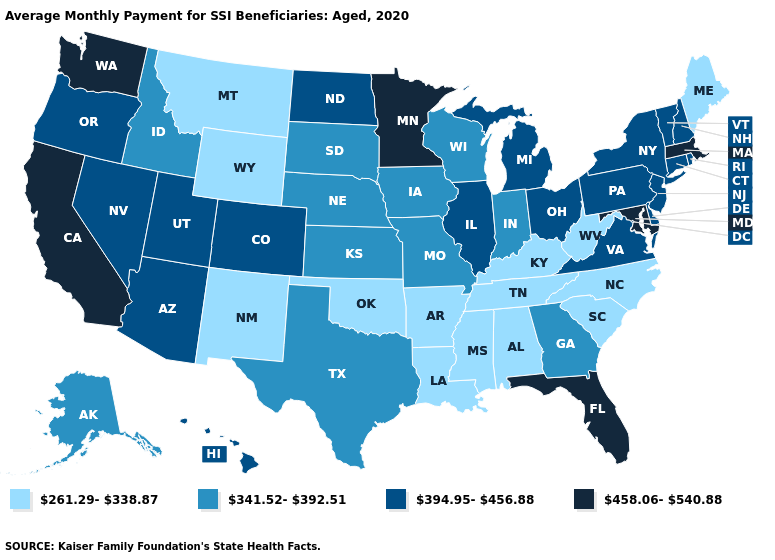Does Arizona have the lowest value in the USA?
Give a very brief answer. No. Among the states that border Tennessee , which have the highest value?
Give a very brief answer. Virginia. Among the states that border Connecticut , which have the lowest value?
Be succinct. New York, Rhode Island. What is the highest value in the USA?
Quick response, please. 458.06-540.88. Is the legend a continuous bar?
Quick response, please. No. What is the value of Delaware?
Answer briefly. 394.95-456.88. What is the value of Texas?
Short answer required. 341.52-392.51. What is the value of Arizona?
Quick response, please. 394.95-456.88. Is the legend a continuous bar?
Quick response, please. No. Does the first symbol in the legend represent the smallest category?
Give a very brief answer. Yes. Name the states that have a value in the range 458.06-540.88?
Short answer required. California, Florida, Maryland, Massachusetts, Minnesota, Washington. Name the states that have a value in the range 261.29-338.87?
Quick response, please. Alabama, Arkansas, Kentucky, Louisiana, Maine, Mississippi, Montana, New Mexico, North Carolina, Oklahoma, South Carolina, Tennessee, West Virginia, Wyoming. Name the states that have a value in the range 394.95-456.88?
Keep it brief. Arizona, Colorado, Connecticut, Delaware, Hawaii, Illinois, Michigan, Nevada, New Hampshire, New Jersey, New York, North Dakota, Ohio, Oregon, Pennsylvania, Rhode Island, Utah, Vermont, Virginia. Name the states that have a value in the range 458.06-540.88?
Quick response, please. California, Florida, Maryland, Massachusetts, Minnesota, Washington. 